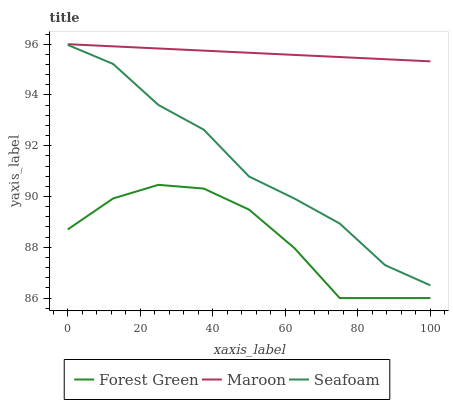Does Forest Green have the minimum area under the curve?
Answer yes or no. Yes. Does Maroon have the maximum area under the curve?
Answer yes or no. Yes. Does Seafoam have the minimum area under the curve?
Answer yes or no. No. Does Seafoam have the maximum area under the curve?
Answer yes or no. No. Is Maroon the smoothest?
Answer yes or no. Yes. Is Forest Green the roughest?
Answer yes or no. Yes. Is Seafoam the smoothest?
Answer yes or no. No. Is Seafoam the roughest?
Answer yes or no. No. Does Forest Green have the lowest value?
Answer yes or no. Yes. Does Seafoam have the lowest value?
Answer yes or no. No. Does Maroon have the highest value?
Answer yes or no. Yes. Does Seafoam have the highest value?
Answer yes or no. No. Is Forest Green less than Seafoam?
Answer yes or no. Yes. Is Seafoam greater than Forest Green?
Answer yes or no. Yes. Does Forest Green intersect Seafoam?
Answer yes or no. No. 